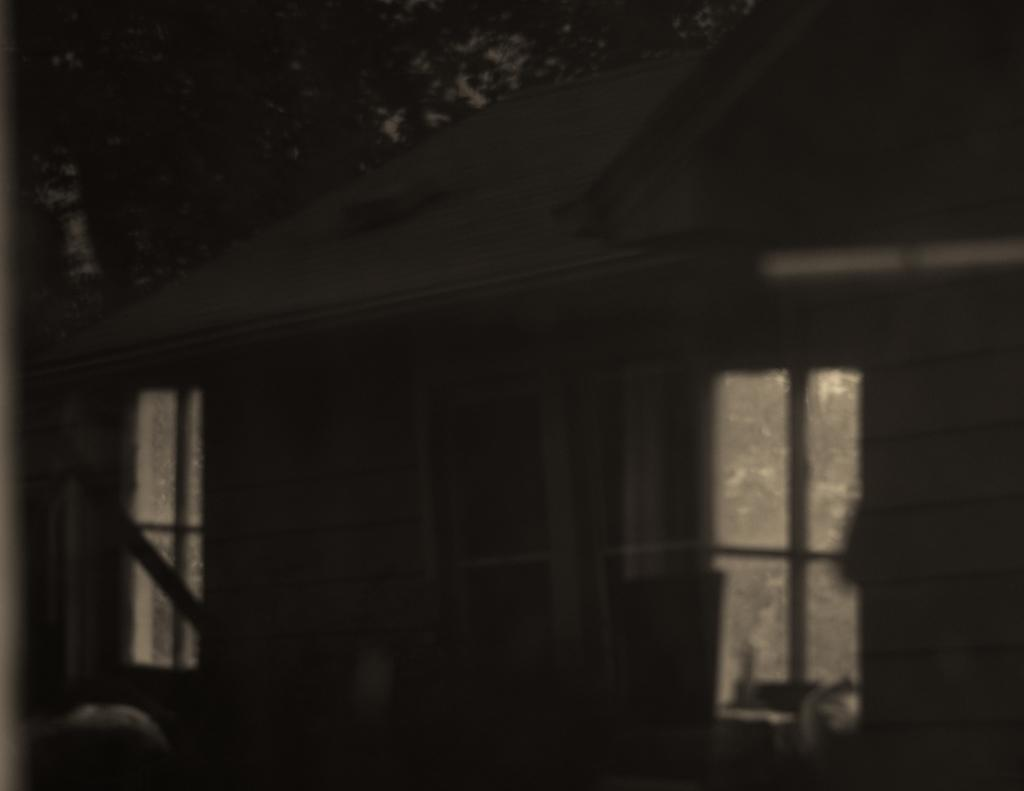What type of structure is present in the image? There is a house in the image. What features can be observed on the house? The house has windows and a roof. What can be seen in the background of the image? There is a tree visible in the background of the image. What is the title of the book that the house is reading in the image? There is no book or reading activity depicted in the image; it only features a house with windows and a roof, along with a tree in the background. 